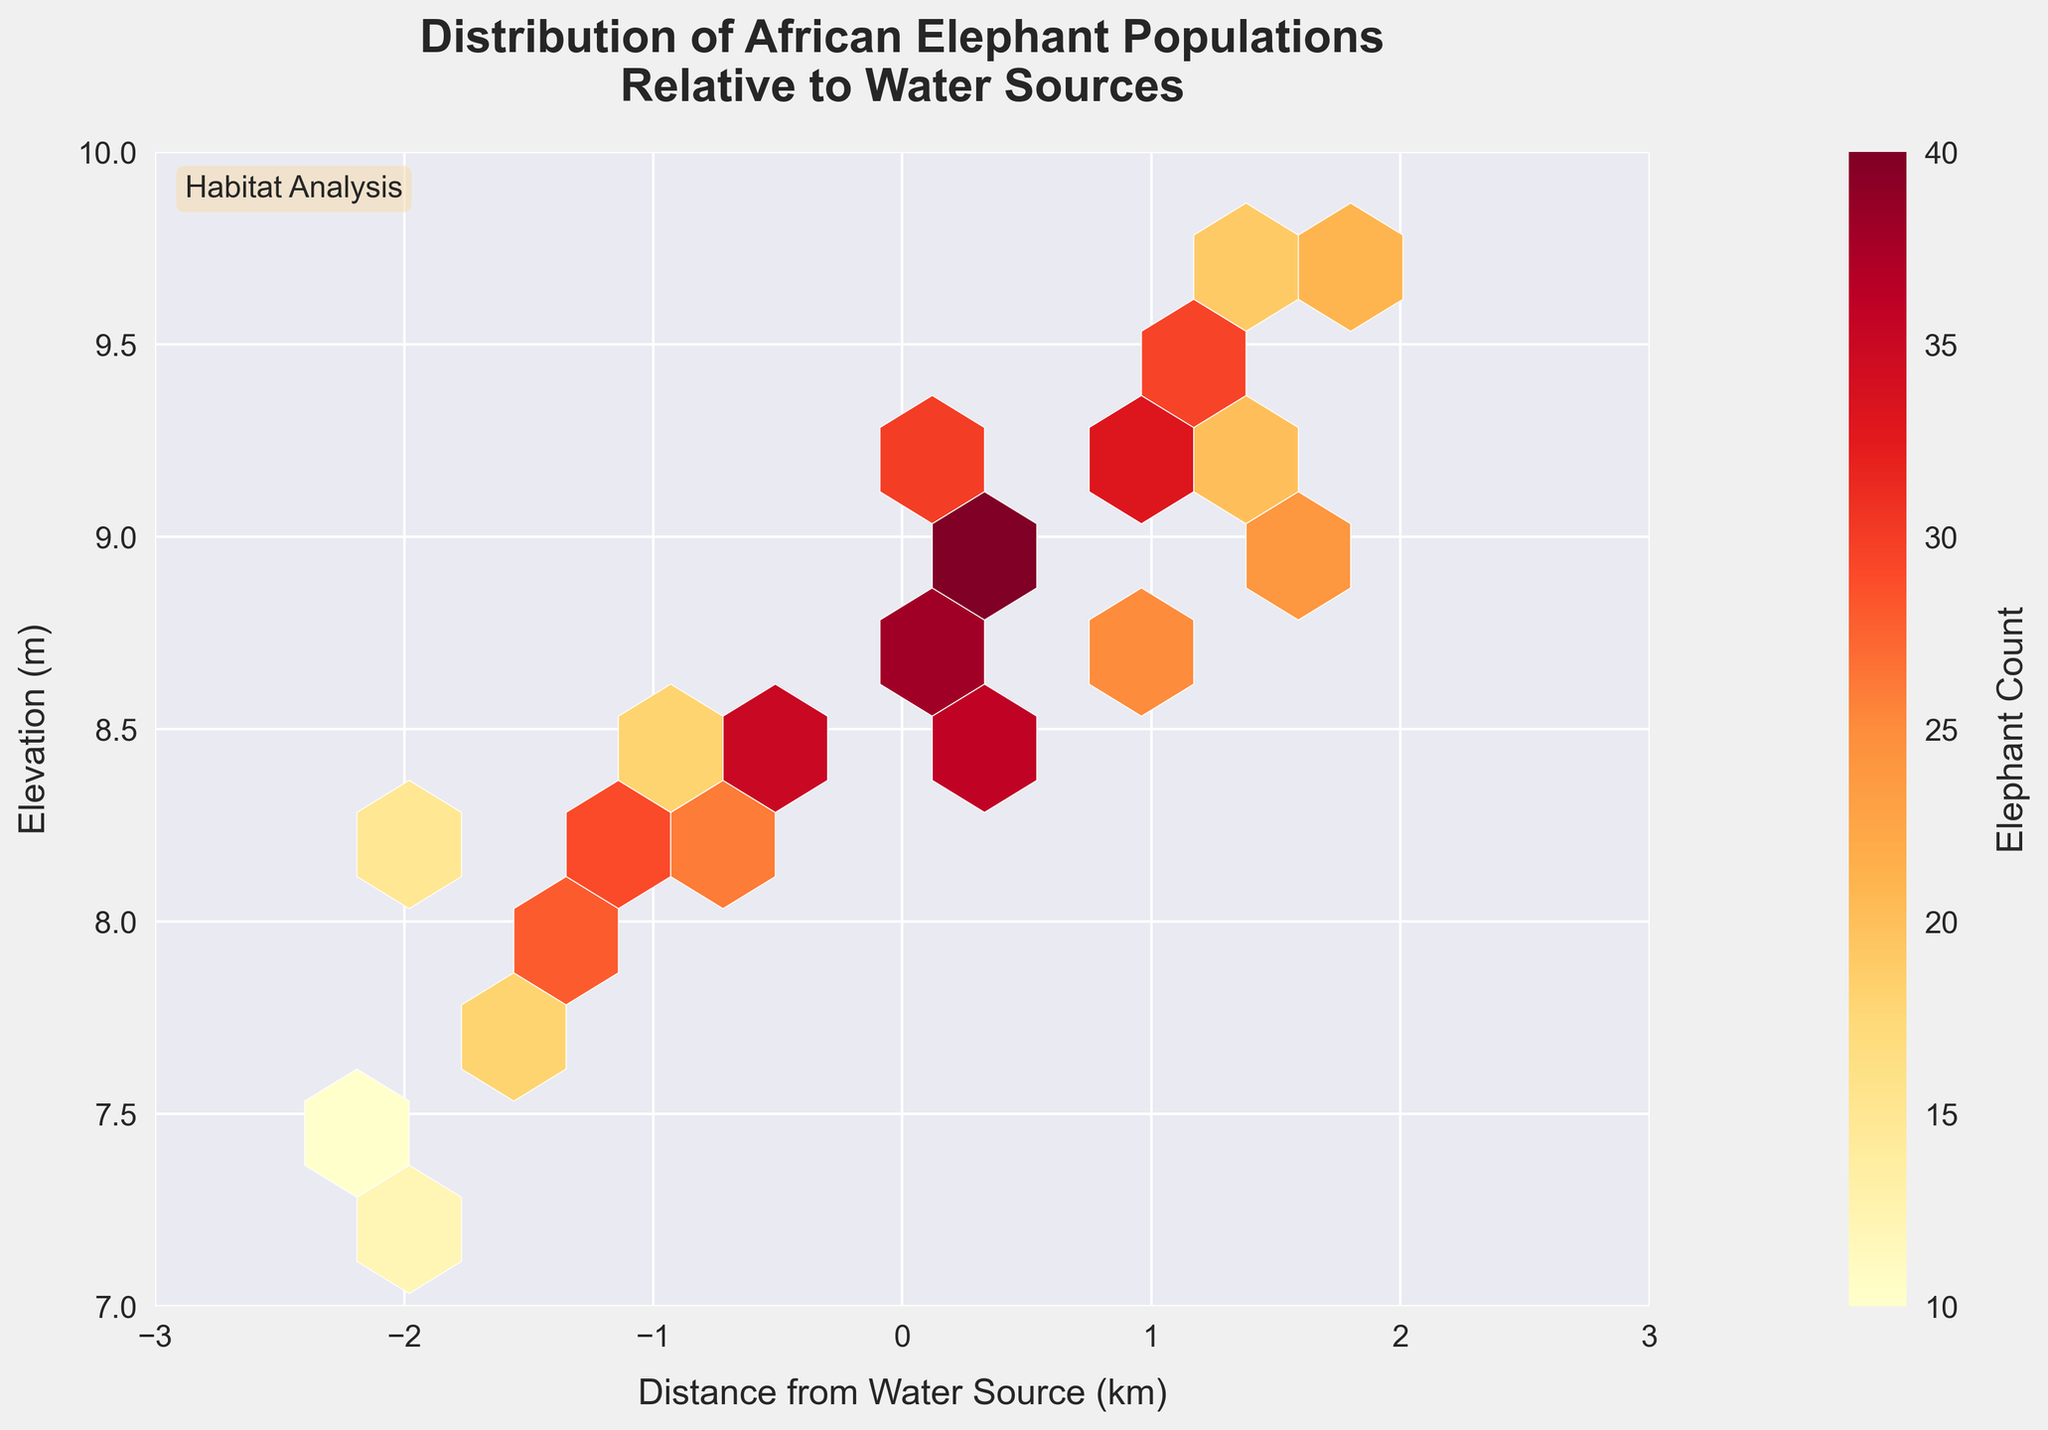What's the title of the figure? The title is given at the top of the figure and provides an overview of what the plot is about. The title reads "Distribution of African Elephant Populations Relative to Water Sources".
Answer: Distribution of African Elephant Populations Relative to Water Sources What do the x and y axes represent? The labels on the x and y axes tell us what these dimensions represent. The x-axis stands for "Distance from Water Source (km)" and the y-axis stands for "Elevation (m)".
Answer: Distance from Water Source (km), Elevation (m) What is the color range used in the hexbin plot? The color range visible in the plot varies from lighter to darker shades of a gradient. The color map used ranges from yellow to dark red.
Answer: Yellow to dark red What does the color intensity in the hexagons indicate? The plot includes a color intensity gradient represented by a color bar on the right. Darker colors indicate a higher count of elephants, while lighter colors indicate lower counts.
Answer: Higher elephant populations What is the highest count of elephants shown in the plot? We look at the color bar and find the maximum value it represents. The highest count indicated by the color bar is 40.
Answer: 40 How does elephant population density correlate with distance from water sources? To understand the correlation, observe how the highest densities (darker hexagons) are distributed along the x-axis. Higher densities appear at closer distances (x < 1 km) to water sources.
Answer: Higher near water sources Which area shows a lower density of elephant populations: higher elevations or lower elevations? By comparing the color intensity across the y-axis, lighter hexagons (indicating lower densities) are generally found at higher elevations (y axis > 9 m).
Answer: Higher elevations Which axis ranges are used for distance from water sources and elevation? The plot’s axes are bounded by specific limits. The x-axis ranges from -3 to 3 km, and the y-axis ranges from 7 to 10 m.
Answer: -3 to 3 km, 7 to 10 m Is there a noticeable concentration of elephant populations at any specific elevation? By examining the hexagons’ concentration and color intensity along the y-axis, there's a noticeable concentration around the 8.5 to 9 m elevation range.
Answer: 8.5 to 9 m In what elevation and distance range is the highest-count hexagon located? Identify the darkest hexagon and note its position relative to the axes. The highest count hexagon is located around 0.5 km from water sources and has an elevation of approximately 8.9 m.
Answer: 0.5 km, 8.9 m 